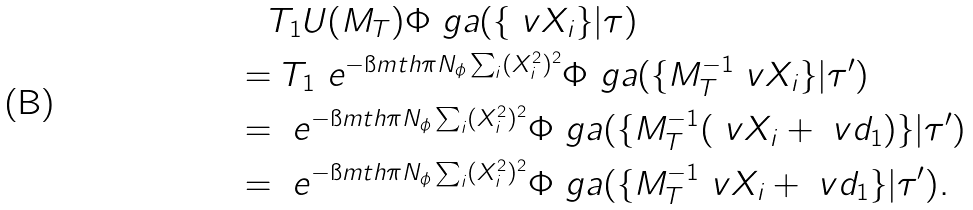<formula> <loc_0><loc_0><loc_500><loc_500>& \quad T _ { 1 } U ( M _ { T } ) \Phi _ { \ } g a ( \{ \ v X _ { i } \} | \tau ) \\ & = T _ { 1 } \ e ^ { - \i m t h \pi N _ { \phi } \sum _ { i } ( X _ { i } ^ { 2 } ) ^ { 2 } } \Phi _ { \ } g a ( \{ M _ { T } ^ { - 1 } \ v X _ { i } \} | \tau ^ { \prime } ) \\ & = \ e ^ { - \i m t h \pi N _ { \phi } \sum _ { i } ( X _ { i } ^ { 2 } ) ^ { 2 } } \Phi _ { \ } g a ( \{ M _ { T } ^ { - 1 } ( \ v X _ { i } + \ v d _ { 1 } ) \} | \tau ^ { \prime } ) \\ & = \ e ^ { - \i m t h \pi N _ { \phi } \sum _ { i } ( X _ { i } ^ { 2 } ) ^ { 2 } } \Phi _ { \ } g a ( \{ M _ { T } ^ { - 1 } \ v X _ { i } + \ v d _ { 1 } \} | \tau ^ { \prime } ) .</formula> 